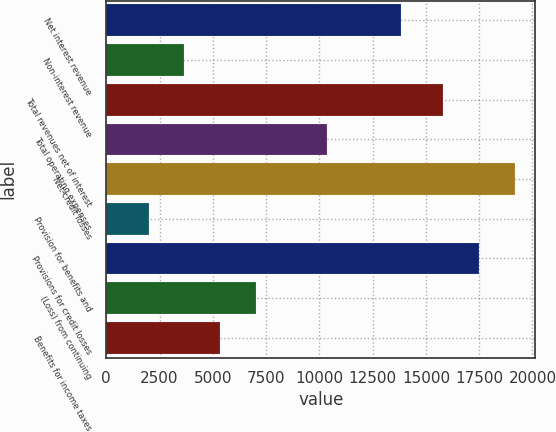Convert chart. <chart><loc_0><loc_0><loc_500><loc_500><bar_chart><fcel>Net interest revenue<fcel>Non-interest revenue<fcel>Total revenues net of interest<fcel>Total operating expenses<fcel>Net credit losses<fcel>Provision for benefits and<fcel>Provisions for credit losses<fcel>(Loss) from continuing<fcel>Benefits for income taxes<nl><fcel>13831<fcel>3667.2<fcel>15826<fcel>10353.6<fcel>19169.2<fcel>1995.6<fcel>17497.6<fcel>7010.4<fcel>5338.8<nl></chart> 